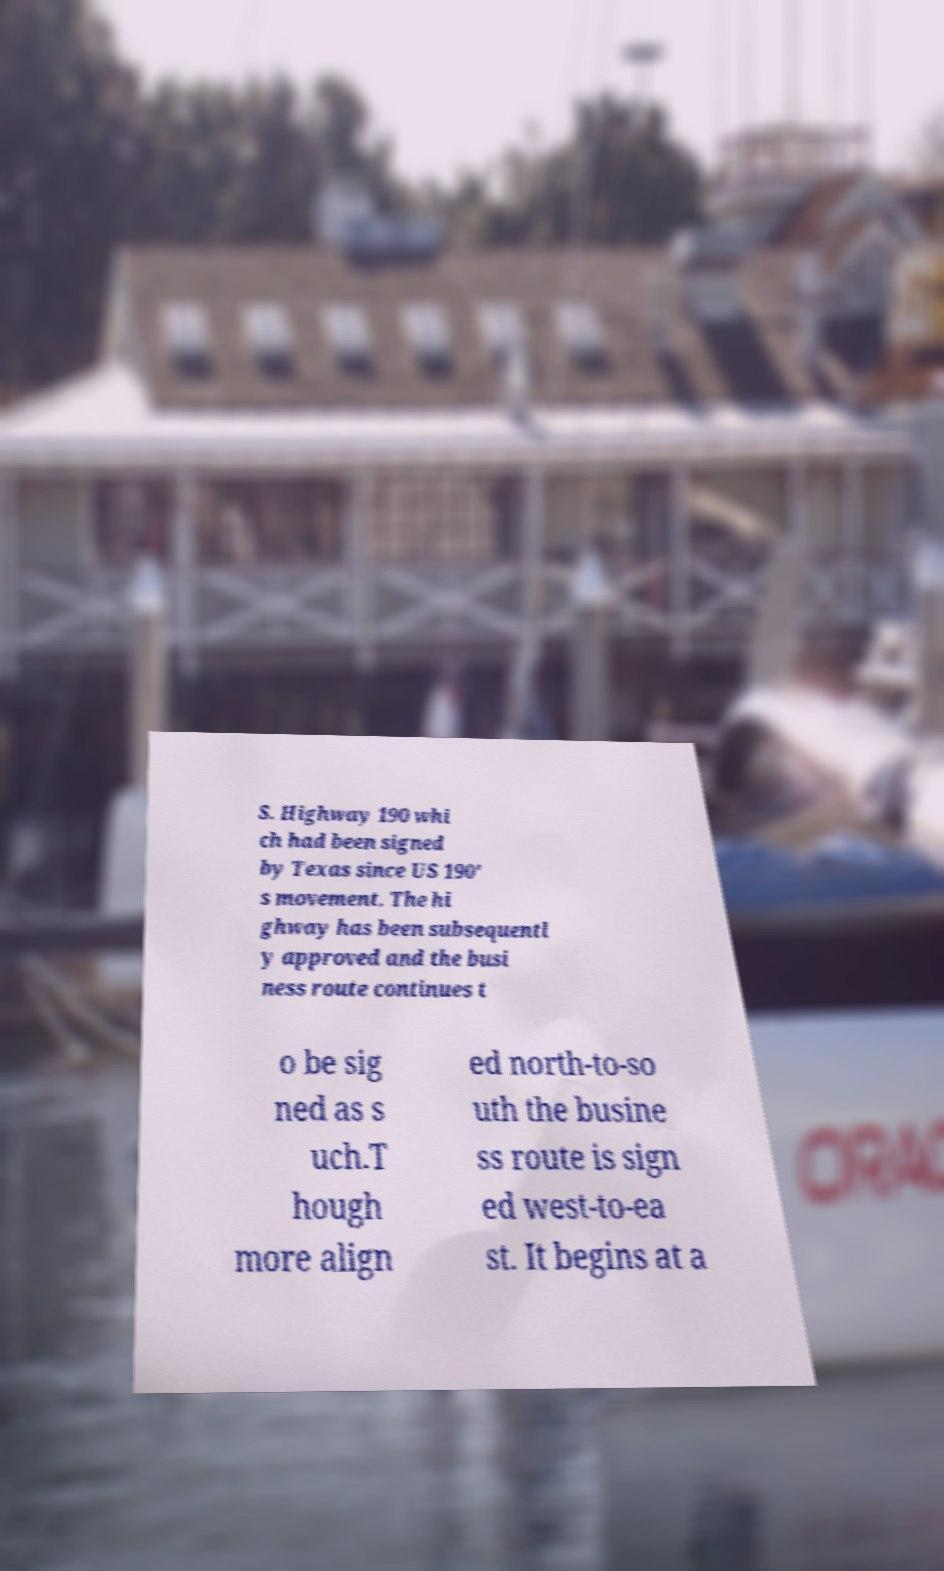Could you assist in decoding the text presented in this image and type it out clearly? S. Highway 190 whi ch had been signed by Texas since US 190' s movement. The hi ghway has been subsequentl y approved and the busi ness route continues t o be sig ned as s uch.T hough more align ed north-to-so uth the busine ss route is sign ed west-to-ea st. It begins at a 